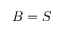Convert formula to latex. <formula><loc_0><loc_0><loc_500><loc_500>B = S</formula> 